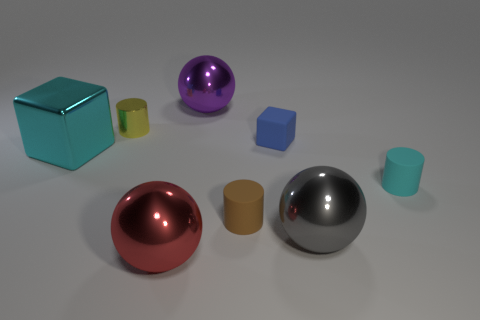Are there more blue rubber blocks than balls?
Offer a terse response. No. What number of rubber objects are both behind the tiny cyan matte thing and in front of the big cyan metallic cube?
Provide a short and direct response. 0. There is a cylinder that is on the left side of the small brown thing; how many gray balls are right of it?
Keep it short and to the point. 1. What number of things are big shiny spheres that are in front of the yellow thing or brown objects in front of the yellow object?
Give a very brief answer. 3. What is the material of the other cyan object that is the same shape as the small metallic object?
Ensure brevity in your answer.  Rubber. How many things are big metal spheres on the right side of the blue matte object or small red objects?
Make the answer very short. 1. There is a big purple thing that is made of the same material as the big cube; what is its shape?
Provide a short and direct response. Sphere. How many other big metallic objects have the same shape as the yellow metallic object?
Your answer should be very brief. 0. What is the tiny yellow cylinder made of?
Make the answer very short. Metal. There is a matte cube; does it have the same color as the big ball that is behind the small yellow shiny object?
Your answer should be very brief. No. 